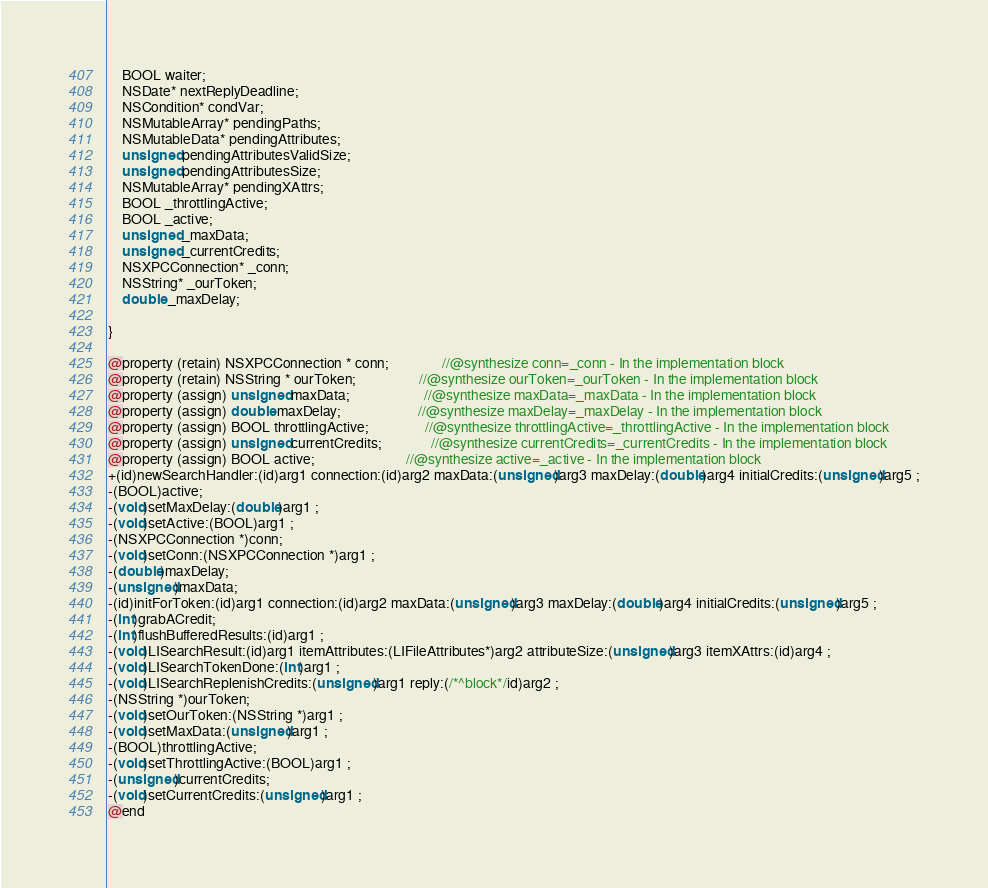Convert code to text. <code><loc_0><loc_0><loc_500><loc_500><_C_>	BOOL waiter;
	NSDate* nextReplyDeadline;
	NSCondition* condVar;
	NSMutableArray* pendingPaths;
	NSMutableData* pendingAttributes;
	unsigned pendingAttributesValidSize;
	unsigned pendingAttributesSize;
	NSMutableArray* pendingXAttrs;
	BOOL _throttlingActive;
	BOOL _active;
	unsigned _maxData;
	unsigned _currentCredits;
	NSXPCConnection* _conn;
	NSString* _ourToken;
	double _maxDelay;

}

@property (retain) NSXPCConnection * conn;               //@synthesize conn=_conn - In the implementation block
@property (retain) NSString * ourToken;                  //@synthesize ourToken=_ourToken - In the implementation block
@property (assign) unsigned maxData;                     //@synthesize maxData=_maxData - In the implementation block
@property (assign) double maxDelay;                      //@synthesize maxDelay=_maxDelay - In the implementation block
@property (assign) BOOL throttlingActive;                //@synthesize throttlingActive=_throttlingActive - In the implementation block
@property (assign) unsigned currentCredits;              //@synthesize currentCredits=_currentCredits - In the implementation block
@property (assign) BOOL active;                          //@synthesize active=_active - In the implementation block
+(id)newSearchHandler:(id)arg1 connection:(id)arg2 maxData:(unsigned)arg3 maxDelay:(double)arg4 initialCredits:(unsigned)arg5 ;
-(BOOL)active;
-(void)setMaxDelay:(double)arg1 ;
-(void)setActive:(BOOL)arg1 ;
-(NSXPCConnection *)conn;
-(void)setConn:(NSXPCConnection *)arg1 ;
-(double)maxDelay;
-(unsigned)maxData;
-(id)initForToken:(id)arg1 connection:(id)arg2 maxData:(unsigned)arg3 maxDelay:(double)arg4 initialCredits:(unsigned)arg5 ;
-(int)grabACredit;
-(int)flushBufferedResults:(id)arg1 ;
-(void)LISearchResult:(id)arg1 itemAttributes:(LIFileAttributes*)arg2 attributeSize:(unsigned)arg3 itemXAttrs:(id)arg4 ;
-(void)LISearchTokenDone:(int)arg1 ;
-(void)LISearchReplenishCredits:(unsigned)arg1 reply:(/*^block*/id)arg2 ;
-(NSString *)ourToken;
-(void)setOurToken:(NSString *)arg1 ;
-(void)setMaxData:(unsigned)arg1 ;
-(BOOL)throttlingActive;
-(void)setThrottlingActive:(BOOL)arg1 ;
-(unsigned)currentCredits;
-(void)setCurrentCredits:(unsigned)arg1 ;
@end

</code> 